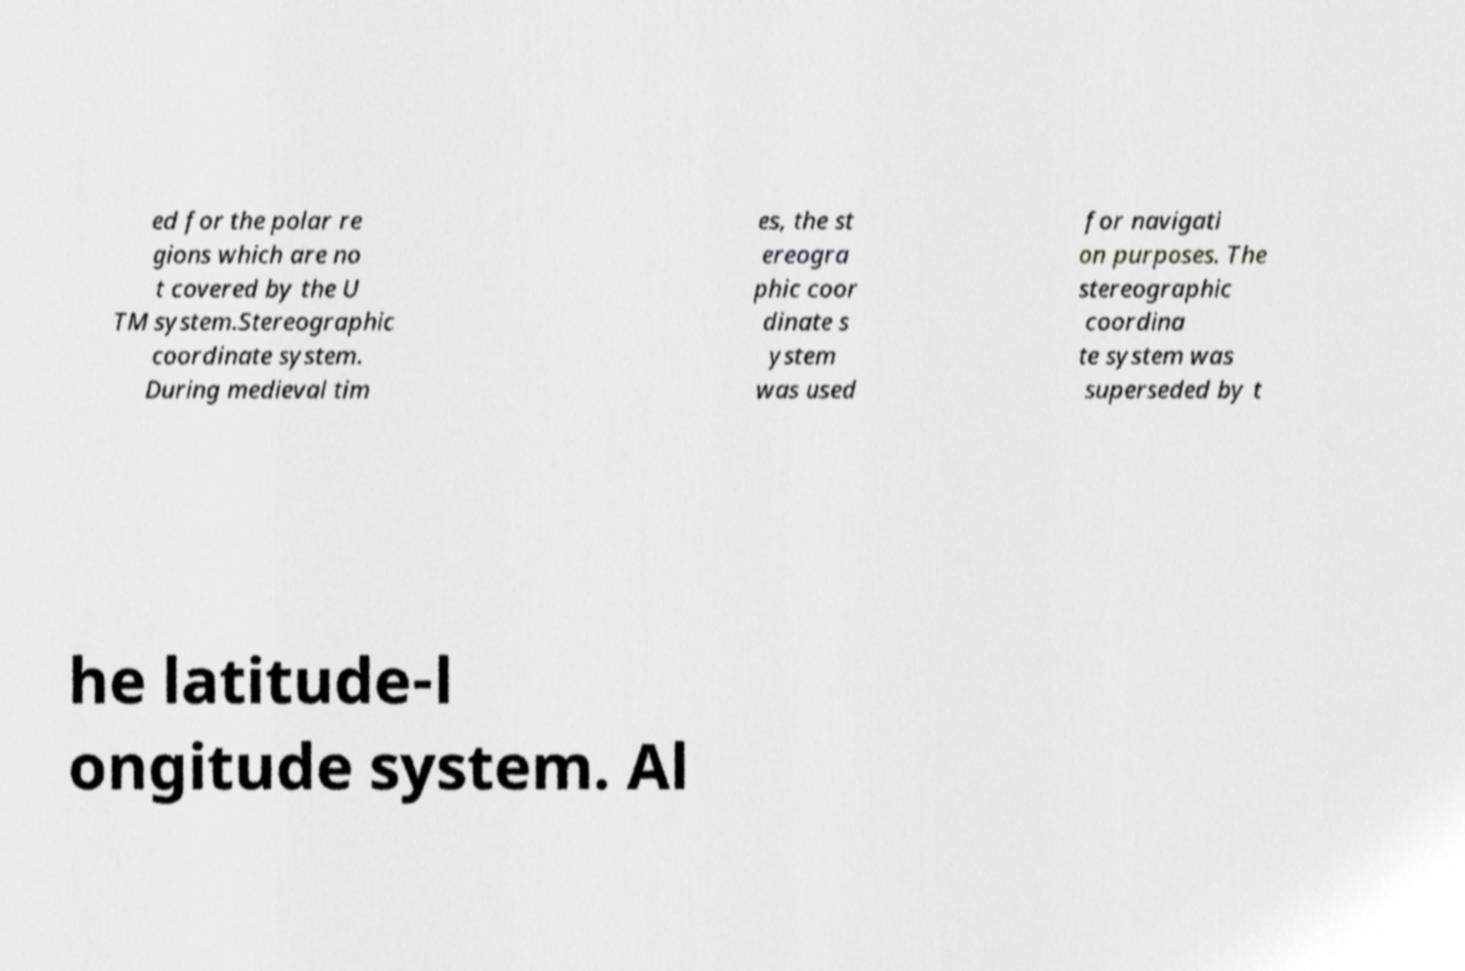There's text embedded in this image that I need extracted. Can you transcribe it verbatim? ed for the polar re gions which are no t covered by the U TM system.Stereographic coordinate system. During medieval tim es, the st ereogra phic coor dinate s ystem was used for navigati on purposes. The stereographic coordina te system was superseded by t he latitude-l ongitude system. Al 